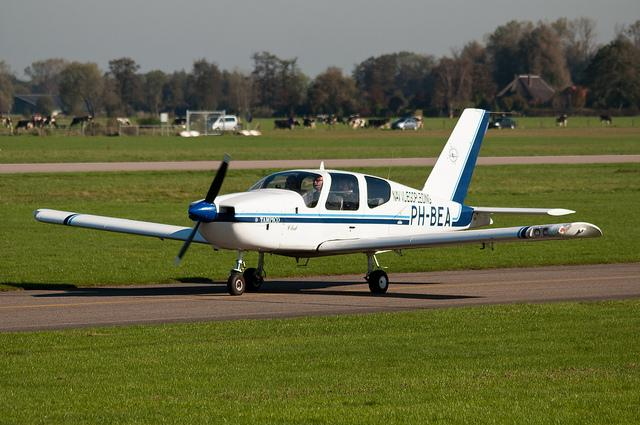What area is behind Plane runway? farm 